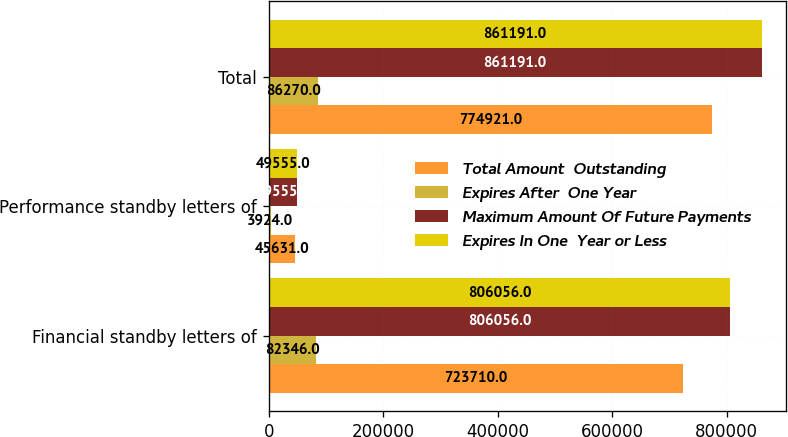Convert chart. <chart><loc_0><loc_0><loc_500><loc_500><stacked_bar_chart><ecel><fcel>Financial standby letters of<fcel>Performance standby letters of<fcel>Total<nl><fcel>Total Amount  Outstanding<fcel>723710<fcel>45631<fcel>774921<nl><fcel>Expires After  One Year<fcel>82346<fcel>3924<fcel>86270<nl><fcel>Maximum Amount Of Future Payments<fcel>806056<fcel>49555<fcel>861191<nl><fcel>Expires In One  Year or Less<fcel>806056<fcel>49555<fcel>861191<nl></chart> 